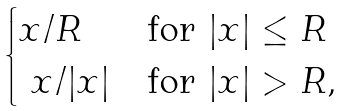Convert formula to latex. <formula><loc_0><loc_0><loc_500><loc_500>\begin{cases} x / R & \text {for} \ | x | \leq R \\ \ x / | x | & \text {for} \ | x | > R , \end{cases}</formula> 